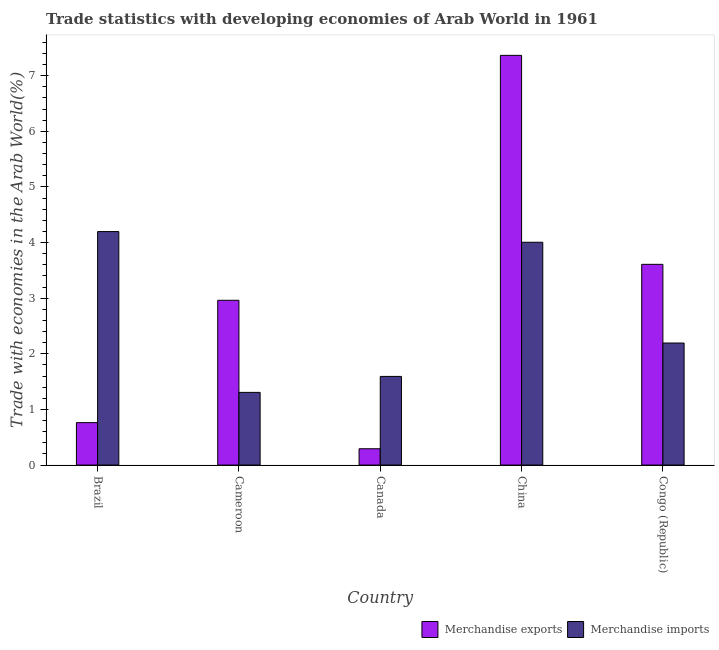How many different coloured bars are there?
Offer a very short reply. 2. How many groups of bars are there?
Keep it short and to the point. 5. Are the number of bars per tick equal to the number of legend labels?
Your response must be concise. Yes. Are the number of bars on each tick of the X-axis equal?
Your response must be concise. Yes. How many bars are there on the 5th tick from the left?
Provide a succinct answer. 2. How many bars are there on the 2nd tick from the right?
Give a very brief answer. 2. What is the label of the 2nd group of bars from the left?
Offer a very short reply. Cameroon. In how many cases, is the number of bars for a given country not equal to the number of legend labels?
Give a very brief answer. 0. What is the merchandise exports in Congo (Republic)?
Ensure brevity in your answer.  3.61. Across all countries, what is the maximum merchandise exports?
Give a very brief answer. 7.36. Across all countries, what is the minimum merchandise exports?
Offer a very short reply. 0.29. In which country was the merchandise imports minimum?
Your answer should be very brief. Cameroon. What is the total merchandise imports in the graph?
Keep it short and to the point. 13.3. What is the difference between the merchandise exports in Cameroon and that in China?
Offer a terse response. -4.4. What is the difference between the merchandise imports in Congo (Republic) and the merchandise exports in Cameroon?
Ensure brevity in your answer.  -0.77. What is the average merchandise imports per country?
Offer a very short reply. 2.66. What is the difference between the merchandise exports and merchandise imports in Canada?
Provide a succinct answer. -1.3. What is the ratio of the merchandise exports in Brazil to that in Congo (Republic)?
Your response must be concise. 0.21. Is the merchandise imports in Cameroon less than that in China?
Make the answer very short. Yes. What is the difference between the highest and the second highest merchandise imports?
Offer a very short reply. 0.19. What is the difference between the highest and the lowest merchandise exports?
Make the answer very short. 7.07. Is the sum of the merchandise exports in Cameroon and Canada greater than the maximum merchandise imports across all countries?
Ensure brevity in your answer.  No. How many countries are there in the graph?
Offer a terse response. 5. What is the title of the graph?
Ensure brevity in your answer.  Trade statistics with developing economies of Arab World in 1961. What is the label or title of the Y-axis?
Ensure brevity in your answer.  Trade with economies in the Arab World(%). What is the Trade with economies in the Arab World(%) in Merchandise exports in Brazil?
Your answer should be very brief. 0.76. What is the Trade with economies in the Arab World(%) of Merchandise imports in Brazil?
Give a very brief answer. 4.2. What is the Trade with economies in the Arab World(%) of Merchandise exports in Cameroon?
Offer a terse response. 2.96. What is the Trade with economies in the Arab World(%) in Merchandise imports in Cameroon?
Offer a very short reply. 1.31. What is the Trade with economies in the Arab World(%) in Merchandise exports in Canada?
Provide a succinct answer. 0.29. What is the Trade with economies in the Arab World(%) in Merchandise imports in Canada?
Provide a succinct answer. 1.59. What is the Trade with economies in the Arab World(%) in Merchandise exports in China?
Provide a short and direct response. 7.36. What is the Trade with economies in the Arab World(%) in Merchandise imports in China?
Provide a short and direct response. 4.01. What is the Trade with economies in the Arab World(%) in Merchandise exports in Congo (Republic)?
Offer a very short reply. 3.61. What is the Trade with economies in the Arab World(%) of Merchandise imports in Congo (Republic)?
Your answer should be very brief. 2.19. Across all countries, what is the maximum Trade with economies in the Arab World(%) of Merchandise exports?
Ensure brevity in your answer.  7.36. Across all countries, what is the maximum Trade with economies in the Arab World(%) of Merchandise imports?
Offer a terse response. 4.2. Across all countries, what is the minimum Trade with economies in the Arab World(%) of Merchandise exports?
Offer a very short reply. 0.29. Across all countries, what is the minimum Trade with economies in the Arab World(%) in Merchandise imports?
Your response must be concise. 1.31. What is the total Trade with economies in the Arab World(%) of Merchandise exports in the graph?
Your answer should be compact. 14.99. What is the total Trade with economies in the Arab World(%) in Merchandise imports in the graph?
Make the answer very short. 13.3. What is the difference between the Trade with economies in the Arab World(%) in Merchandise exports in Brazil and that in Cameroon?
Make the answer very short. -2.2. What is the difference between the Trade with economies in the Arab World(%) in Merchandise imports in Brazil and that in Cameroon?
Your answer should be compact. 2.89. What is the difference between the Trade with economies in the Arab World(%) of Merchandise exports in Brazil and that in Canada?
Your response must be concise. 0.47. What is the difference between the Trade with economies in the Arab World(%) in Merchandise imports in Brazil and that in Canada?
Ensure brevity in your answer.  2.6. What is the difference between the Trade with economies in the Arab World(%) of Merchandise exports in Brazil and that in China?
Provide a short and direct response. -6.6. What is the difference between the Trade with economies in the Arab World(%) of Merchandise imports in Brazil and that in China?
Provide a short and direct response. 0.19. What is the difference between the Trade with economies in the Arab World(%) in Merchandise exports in Brazil and that in Congo (Republic)?
Your answer should be very brief. -2.85. What is the difference between the Trade with economies in the Arab World(%) of Merchandise imports in Brazil and that in Congo (Republic)?
Give a very brief answer. 2. What is the difference between the Trade with economies in the Arab World(%) of Merchandise exports in Cameroon and that in Canada?
Keep it short and to the point. 2.67. What is the difference between the Trade with economies in the Arab World(%) in Merchandise imports in Cameroon and that in Canada?
Keep it short and to the point. -0.29. What is the difference between the Trade with economies in the Arab World(%) in Merchandise exports in Cameroon and that in China?
Provide a short and direct response. -4.4. What is the difference between the Trade with economies in the Arab World(%) in Merchandise imports in Cameroon and that in China?
Make the answer very short. -2.7. What is the difference between the Trade with economies in the Arab World(%) of Merchandise exports in Cameroon and that in Congo (Republic)?
Provide a short and direct response. -0.65. What is the difference between the Trade with economies in the Arab World(%) in Merchandise imports in Cameroon and that in Congo (Republic)?
Provide a succinct answer. -0.89. What is the difference between the Trade with economies in the Arab World(%) of Merchandise exports in Canada and that in China?
Provide a short and direct response. -7.07. What is the difference between the Trade with economies in the Arab World(%) in Merchandise imports in Canada and that in China?
Offer a very short reply. -2.41. What is the difference between the Trade with economies in the Arab World(%) in Merchandise exports in Canada and that in Congo (Republic)?
Offer a very short reply. -3.31. What is the difference between the Trade with economies in the Arab World(%) in Merchandise imports in Canada and that in Congo (Republic)?
Offer a terse response. -0.6. What is the difference between the Trade with economies in the Arab World(%) of Merchandise exports in China and that in Congo (Republic)?
Your response must be concise. 3.76. What is the difference between the Trade with economies in the Arab World(%) of Merchandise imports in China and that in Congo (Republic)?
Your answer should be very brief. 1.81. What is the difference between the Trade with economies in the Arab World(%) of Merchandise exports in Brazil and the Trade with economies in the Arab World(%) of Merchandise imports in Cameroon?
Provide a short and direct response. -0.54. What is the difference between the Trade with economies in the Arab World(%) of Merchandise exports in Brazil and the Trade with economies in the Arab World(%) of Merchandise imports in Canada?
Give a very brief answer. -0.83. What is the difference between the Trade with economies in the Arab World(%) in Merchandise exports in Brazil and the Trade with economies in the Arab World(%) in Merchandise imports in China?
Your response must be concise. -3.24. What is the difference between the Trade with economies in the Arab World(%) of Merchandise exports in Brazil and the Trade with economies in the Arab World(%) of Merchandise imports in Congo (Republic)?
Give a very brief answer. -1.43. What is the difference between the Trade with economies in the Arab World(%) of Merchandise exports in Cameroon and the Trade with economies in the Arab World(%) of Merchandise imports in Canada?
Your response must be concise. 1.37. What is the difference between the Trade with economies in the Arab World(%) of Merchandise exports in Cameroon and the Trade with economies in the Arab World(%) of Merchandise imports in China?
Give a very brief answer. -1.04. What is the difference between the Trade with economies in the Arab World(%) in Merchandise exports in Cameroon and the Trade with economies in the Arab World(%) in Merchandise imports in Congo (Republic)?
Your response must be concise. 0.77. What is the difference between the Trade with economies in the Arab World(%) of Merchandise exports in Canada and the Trade with economies in the Arab World(%) of Merchandise imports in China?
Provide a short and direct response. -3.71. What is the difference between the Trade with economies in the Arab World(%) in Merchandise exports in Canada and the Trade with economies in the Arab World(%) in Merchandise imports in Congo (Republic)?
Ensure brevity in your answer.  -1.9. What is the difference between the Trade with economies in the Arab World(%) of Merchandise exports in China and the Trade with economies in the Arab World(%) of Merchandise imports in Congo (Republic)?
Your answer should be very brief. 5.17. What is the average Trade with economies in the Arab World(%) in Merchandise exports per country?
Provide a short and direct response. 3. What is the average Trade with economies in the Arab World(%) of Merchandise imports per country?
Provide a succinct answer. 2.66. What is the difference between the Trade with economies in the Arab World(%) of Merchandise exports and Trade with economies in the Arab World(%) of Merchandise imports in Brazil?
Keep it short and to the point. -3.43. What is the difference between the Trade with economies in the Arab World(%) of Merchandise exports and Trade with economies in the Arab World(%) of Merchandise imports in Cameroon?
Offer a terse response. 1.66. What is the difference between the Trade with economies in the Arab World(%) of Merchandise exports and Trade with economies in the Arab World(%) of Merchandise imports in Canada?
Your answer should be very brief. -1.3. What is the difference between the Trade with economies in the Arab World(%) in Merchandise exports and Trade with economies in the Arab World(%) in Merchandise imports in China?
Ensure brevity in your answer.  3.36. What is the difference between the Trade with economies in the Arab World(%) of Merchandise exports and Trade with economies in the Arab World(%) of Merchandise imports in Congo (Republic)?
Make the answer very short. 1.41. What is the ratio of the Trade with economies in the Arab World(%) in Merchandise exports in Brazil to that in Cameroon?
Offer a very short reply. 0.26. What is the ratio of the Trade with economies in the Arab World(%) of Merchandise imports in Brazil to that in Cameroon?
Your answer should be very brief. 3.21. What is the ratio of the Trade with economies in the Arab World(%) in Merchandise exports in Brazil to that in Canada?
Keep it short and to the point. 2.6. What is the ratio of the Trade with economies in the Arab World(%) in Merchandise imports in Brazil to that in Canada?
Provide a succinct answer. 2.63. What is the ratio of the Trade with economies in the Arab World(%) of Merchandise exports in Brazil to that in China?
Ensure brevity in your answer.  0.1. What is the ratio of the Trade with economies in the Arab World(%) of Merchandise imports in Brazil to that in China?
Offer a very short reply. 1.05. What is the ratio of the Trade with economies in the Arab World(%) in Merchandise exports in Brazil to that in Congo (Republic)?
Give a very brief answer. 0.21. What is the ratio of the Trade with economies in the Arab World(%) in Merchandise imports in Brazil to that in Congo (Republic)?
Your answer should be very brief. 1.91. What is the ratio of the Trade with economies in the Arab World(%) in Merchandise exports in Cameroon to that in Canada?
Your response must be concise. 10.1. What is the ratio of the Trade with economies in the Arab World(%) of Merchandise imports in Cameroon to that in Canada?
Provide a short and direct response. 0.82. What is the ratio of the Trade with economies in the Arab World(%) of Merchandise exports in Cameroon to that in China?
Ensure brevity in your answer.  0.4. What is the ratio of the Trade with economies in the Arab World(%) of Merchandise imports in Cameroon to that in China?
Give a very brief answer. 0.33. What is the ratio of the Trade with economies in the Arab World(%) in Merchandise exports in Cameroon to that in Congo (Republic)?
Your answer should be very brief. 0.82. What is the ratio of the Trade with economies in the Arab World(%) of Merchandise imports in Cameroon to that in Congo (Republic)?
Offer a terse response. 0.6. What is the ratio of the Trade with economies in the Arab World(%) of Merchandise exports in Canada to that in China?
Ensure brevity in your answer.  0.04. What is the ratio of the Trade with economies in the Arab World(%) in Merchandise imports in Canada to that in China?
Provide a short and direct response. 0.4. What is the ratio of the Trade with economies in the Arab World(%) of Merchandise exports in Canada to that in Congo (Republic)?
Ensure brevity in your answer.  0.08. What is the ratio of the Trade with economies in the Arab World(%) of Merchandise imports in Canada to that in Congo (Republic)?
Your response must be concise. 0.73. What is the ratio of the Trade with economies in the Arab World(%) in Merchandise exports in China to that in Congo (Republic)?
Offer a terse response. 2.04. What is the ratio of the Trade with economies in the Arab World(%) in Merchandise imports in China to that in Congo (Republic)?
Keep it short and to the point. 1.83. What is the difference between the highest and the second highest Trade with economies in the Arab World(%) in Merchandise exports?
Your answer should be very brief. 3.76. What is the difference between the highest and the second highest Trade with economies in the Arab World(%) in Merchandise imports?
Ensure brevity in your answer.  0.19. What is the difference between the highest and the lowest Trade with economies in the Arab World(%) of Merchandise exports?
Provide a succinct answer. 7.07. What is the difference between the highest and the lowest Trade with economies in the Arab World(%) of Merchandise imports?
Keep it short and to the point. 2.89. 